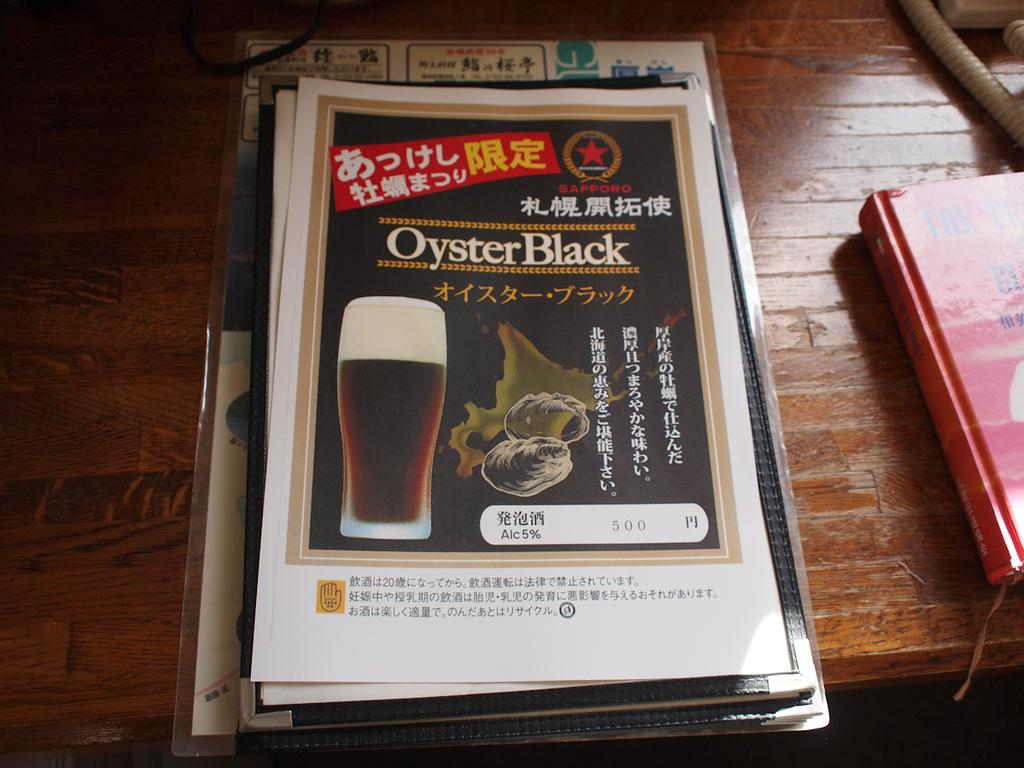What is located in the center of the image? There are posters in the center of the image. Where are the posters placed? The posters are placed on a table. What can be seen on the right side of the image? There is a book on the right side of the image. What channel is the plough featured on in the image? There is no plough or channel present in the image. 